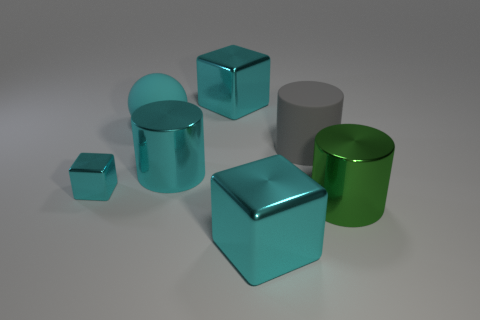Add 1 blue shiny cylinders. How many objects exist? 8 Subtract all cubes. How many objects are left? 4 Add 5 big cyan spheres. How many big cyan spheres exist? 6 Subtract 0 purple blocks. How many objects are left? 7 Subtract all green cylinders. Subtract all gray cylinders. How many objects are left? 5 Add 2 big spheres. How many big spheres are left? 3 